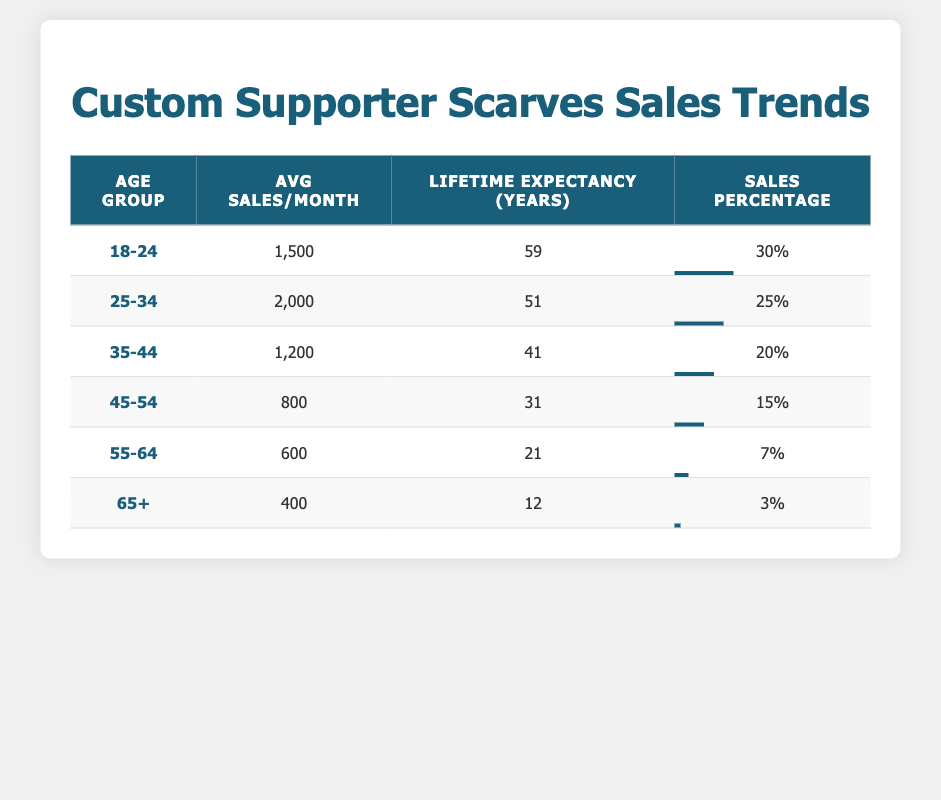What are the average sales per month for the age group 25-34? The table clearly states that for the age group 25-34, the average sales per month is listed as 2000.
Answer: 2000 Which age group has the highest sales percentage? By examining the sales percentage column, we can see that the age group 18-24 has the highest percentage at 30%.
Answer: 18-24 What is the total average sales per month for customers aged 45 and above? To find this, we need to add the average sales for the age groups 45-54 (800), 55-64 (600), and 65+ (400). So, 800 + 600 + 400 = 1800.
Answer: 1800 Is it true that the lifetime expectancy for the age group 55-64 is more than 25 years? The table indicates that the lifetime expectancy for the age group 55-64 is 21 years, which is less than 25 years, making the statement false.
Answer: False How many age groups have an average sales per month greater than 1000? From the table, the age groups 18-24 (1500), 25-34 (2000), and 35-44 (1200) have average sales greater than 1000. This totals to 3 age groups.
Answer: 3 What is the difference in lifetime expectancy between the age groups 45-54 and 35-44? The lifetime expectancy for the age group 45-54 is 31 years, and for the age group 35-44 it is 41 years. The difference is calculated as 41 - 31 = 10 years.
Answer: 10 years What is the average sales per month for the youngest age group? The youngest age group, 18-24, has an average sales per month of 1500, as stated in the table.
Answer: 1500 Is the sales percentage for the age group 65+ higher than that for 55-64? The sales percentage for the age group 65+ is 3%, while for 55-64 it is 7%. Therefore, 3% is not higher than 7%, making the statement false.
Answer: False What is the average lifetime expectancy for all age groups combined? To calculate this average, we sum the lifetime expectancy for all age groups: 59 + 51 + 41 + 31 + 21 + 12 = 215. There are 6 age groups, so the average is 215/6 ≈ 35.83 years.
Answer: 35.83 years 